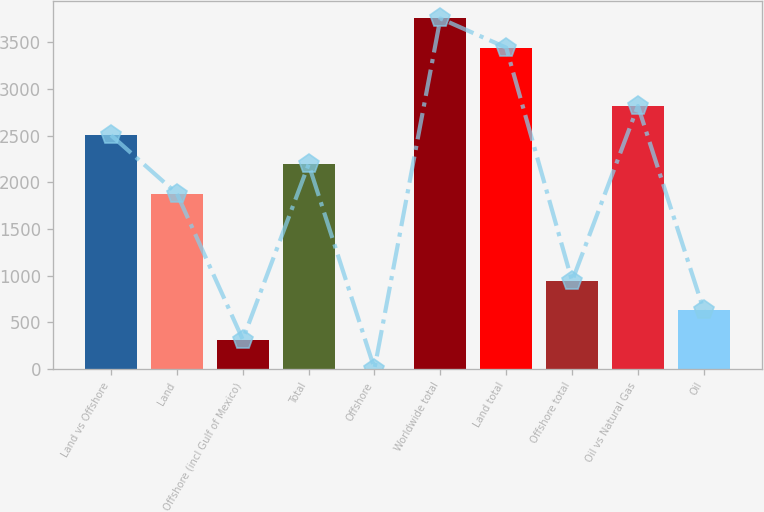Convert chart. <chart><loc_0><loc_0><loc_500><loc_500><bar_chart><fcel>Land vs Offshore<fcel>Land<fcel>Offshore (incl Gulf of Mexico)<fcel>Total<fcel>Offshore<fcel>Worldwide total<fcel>Land total<fcel>Offshore total<fcel>Oil vs Natural Gas<fcel>Oil<nl><fcel>2503.8<fcel>1878.6<fcel>315.6<fcel>2191.2<fcel>3<fcel>3754.2<fcel>3441.6<fcel>940.8<fcel>2816.4<fcel>628.2<nl></chart> 